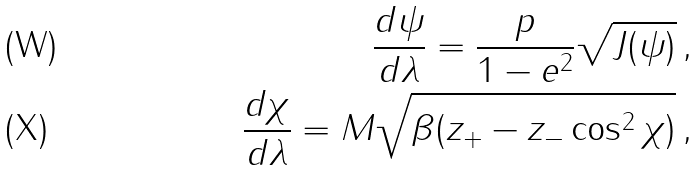Convert formula to latex. <formula><loc_0><loc_0><loc_500><loc_500>\frac { d \psi } { d \lambda } = \frac { p } { 1 - e ^ { 2 } } \sqrt { J ( \psi ) } \, , \\ \frac { d \chi } { d \lambda } = M \sqrt { \beta ( z _ { + } - z _ { - } \cos ^ { 2 } \chi ) } \, ,</formula> 